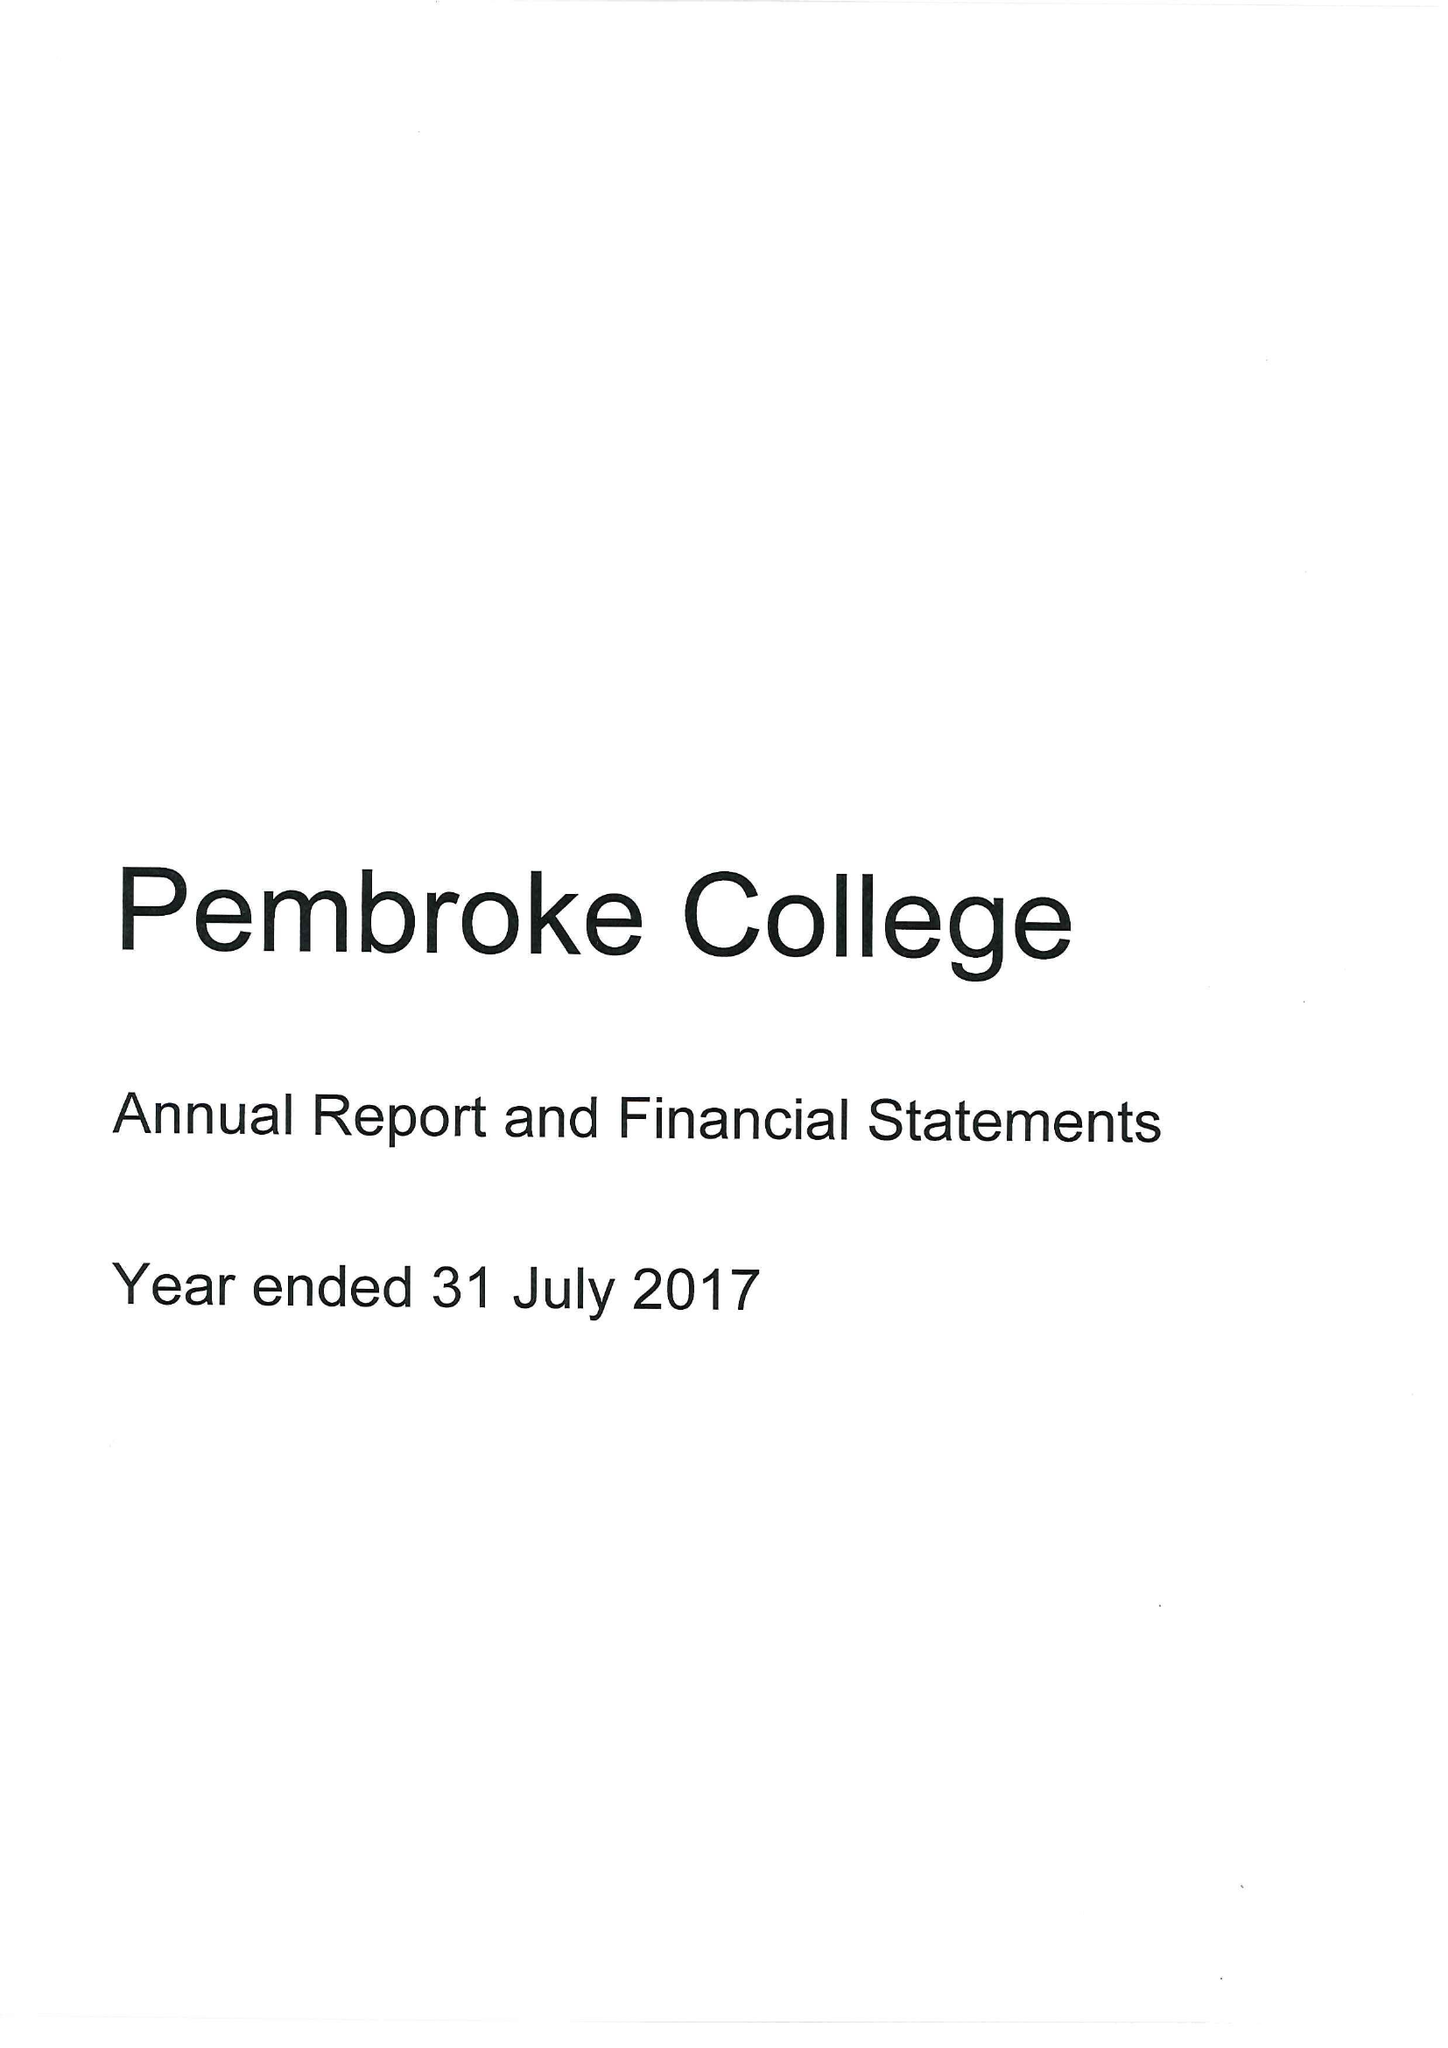What is the value for the address__street_line?
Answer the question using a single word or phrase. ST ALDATES 